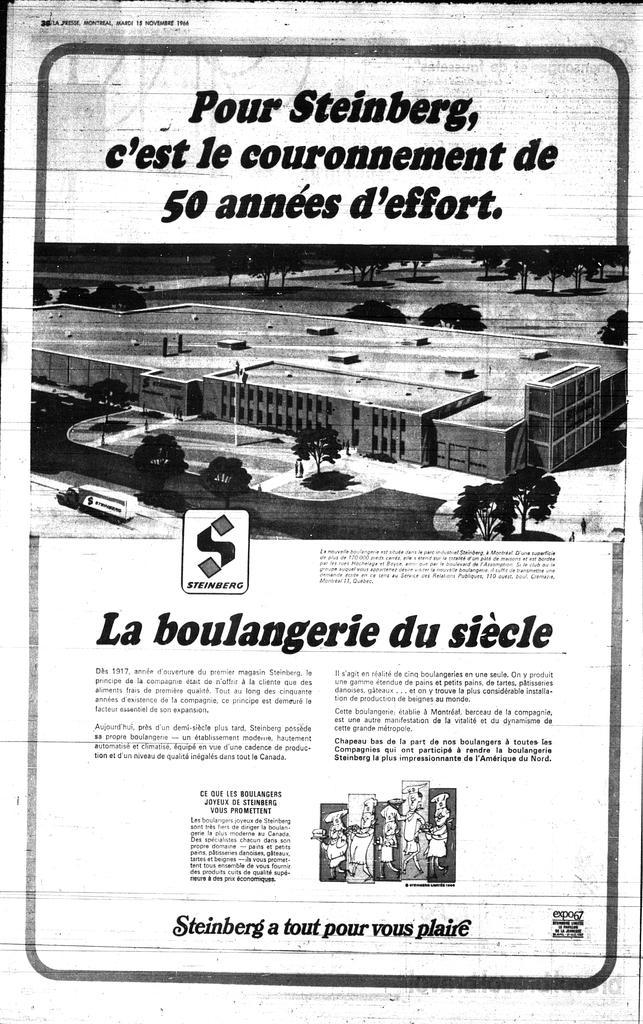Can you describe this image briefly? In this image, we can see a poster. In the middle of the image, we can see a picture. In that picture,we can see a building, pole, trees, road and vehicle. At the top and bottom of the image, we can see some information, logo and figures. 